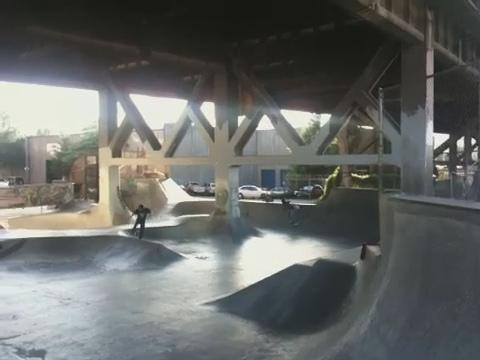Why are there mounds on the surface? Please explain your reasoning. for tricks. The mounds are for tricks. 